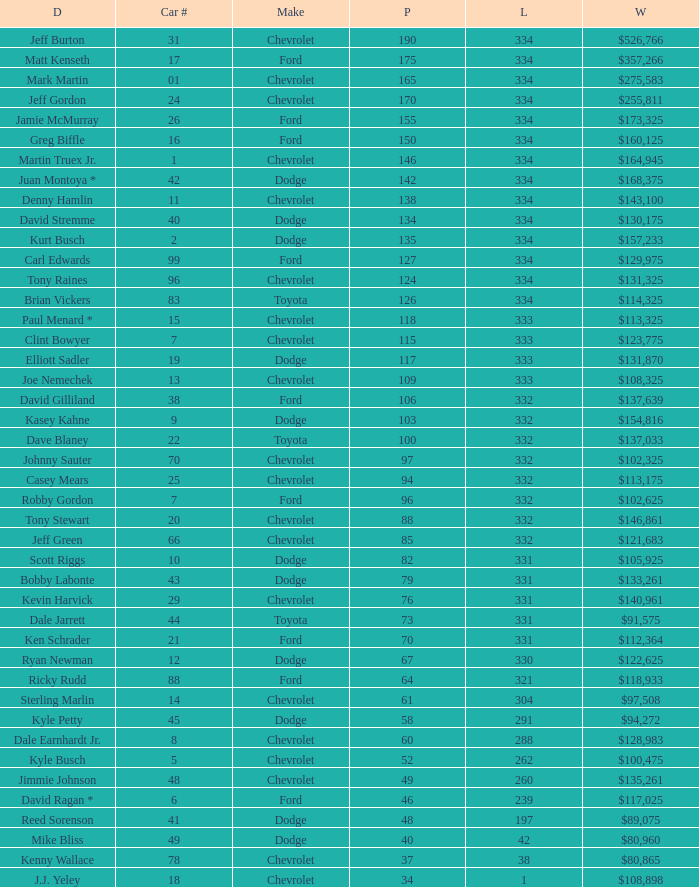How many total laps did the Chevrolet that won $97,508 make? 1.0. 